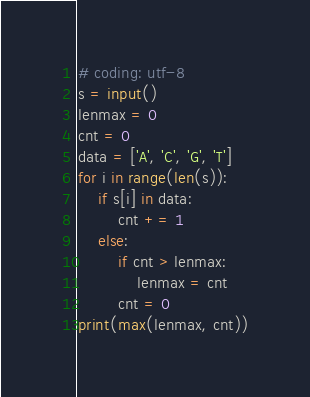Convert code to text. <code><loc_0><loc_0><loc_500><loc_500><_Python_># coding: utf-8
s = input()
lenmax = 0
cnt = 0
data = ['A', 'C', 'G', 'T']
for i in range(len(s)):
    if s[i] in data:
        cnt += 1
    else:
        if cnt > lenmax:
            lenmax = cnt
        cnt = 0
print(max(lenmax, cnt))
</code> 